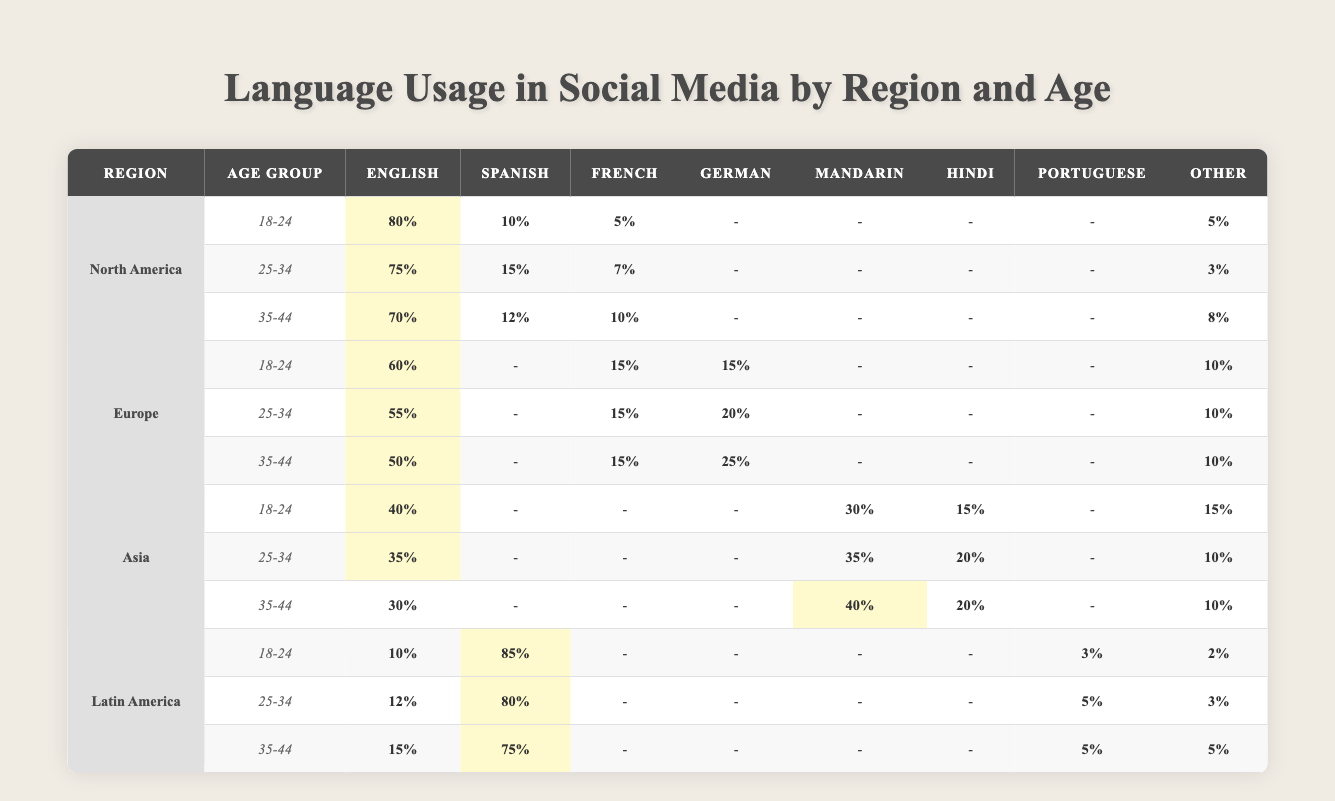What is the percentage of English language usage among 25-34 year olds in North America? Referring to the table, the percentage of English language usage for the age group 25-34 in North America is highlighted and shown as 75%.
Answer: 75% Which region has the highest percentage of Spanish usage for the age group 18-24? By examining the table, the highest percentage of Spanish usage for the age group 18-24 is in Latin America, with 85%, compared to North America (10%), Europe, and Asia (none).
Answer: Latin America What is the total percentage of languages used other than English and Spanish for the age group 35-44 in Europe? In Europe for the age group 35-44, the languages used other than English (50%), Spanish (none), and the total for French (15%), German (25%), and Other (10%) is summed: 15 + 25 + 10 = 50%.
Answer: 50% Is it true that more people aged 18-24 in Asia use Mandarin than those in North America use French? The table shows 30% of the 18-24 age group in Asia use Mandarin, whereas in North America, only 5% of the same age group use French. Therefore, it’s true that more people in Asia use Mandarin than those in North America using French.
Answer: True What is the average percentage of English language usage across all age groups in Latin America? The percentages for English in Latin America are 10%, 12%, and 15% for the age groups 18-24, 25-34, and 35-44 respectively. Adding these: 10 + 12 + 15 = 37, and then dividing by 3 gives the average: 37/3 = 12.33%.
Answer: 12.33% Which age group in North America shows the largest drop in English usage compared to the previous age group? The English usage percentages in North America drop from 80% (18-24) to 75% (25-34), and then again to 70% (35-44). The largest drop is from 80% to 75%, which is a decrease of 5%. Comparing drops: from 75% to 70% is a decrease of 5% again, but the first drop is the largest relative to the previous percentage.
Answer: 5% What percentage of 35-44 year olds in Asia use Hindi? From the table, 20% of the 35-44 age group in Asia use Hindi, as indicated directly in the relevant cell.
Answer: 20% In Europe, which language saw the greatest percentage increase from the 18-24 age group to the 35-44 age group? Looking at the language usage trends from the table in Europe, for German, usage increases from 15% (18-24) to 25% (35-44), which is the greatest increase of 10%. French remains constant at 15%, with no increase.
Answer: German (10% increase) What is the difference in Mandarin usage between the age groups 25-34 and 35-44 in Asia? In Asia, for the 25-34 age group, Mandarin usage is 35%, and for the 35-44 age group, it is 40%. The difference is thus calculated as 40% - 35% = 5%.
Answer: 5% Is the percentage of English usage among 35-44 year olds in North America higher than the same age group in Latin America? In North America, the English usage for 35-44 year olds is 70%, while in Latin America, it is 15%. Therefore, the statement is true as 70% is higher than 15%.
Answer: True 